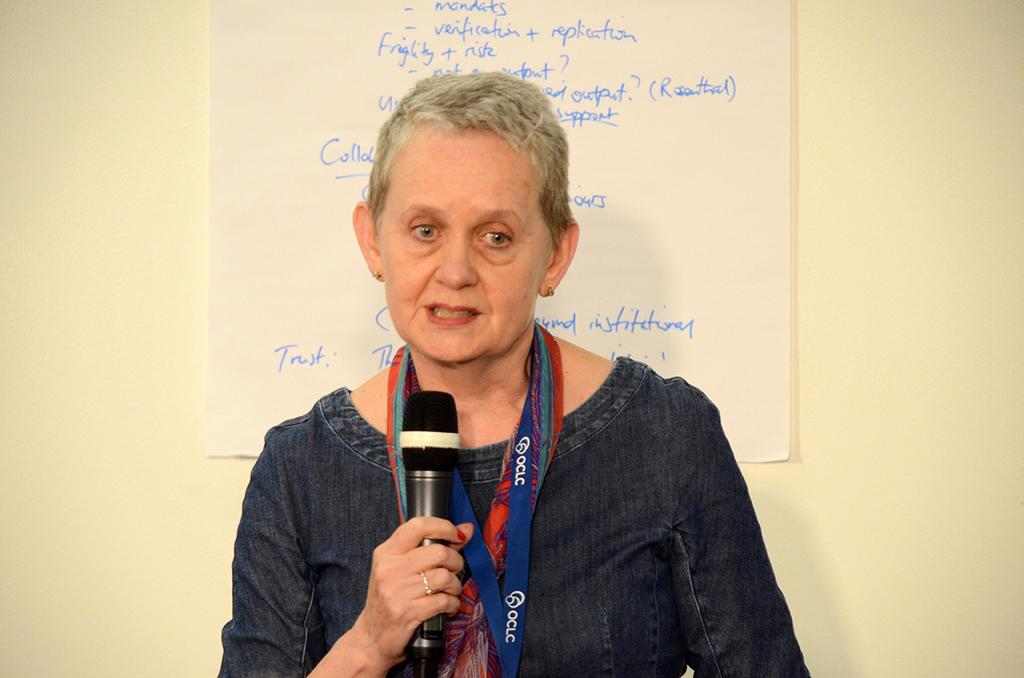Who is the main subject in the image? There is a woman in the image. What is the woman holding in her hand? The woman is holding a microphone in her hand. Can you describe the background of the image? There is a paper with text on it in the background. Where is the paper with text located? The paper is on a wall. What type of bottle is visible on the woman's head in the image? There is no bottle visible on the woman's head in the image. Can you tell me how many clubs are present in the image? There are no clubs present in the image. 